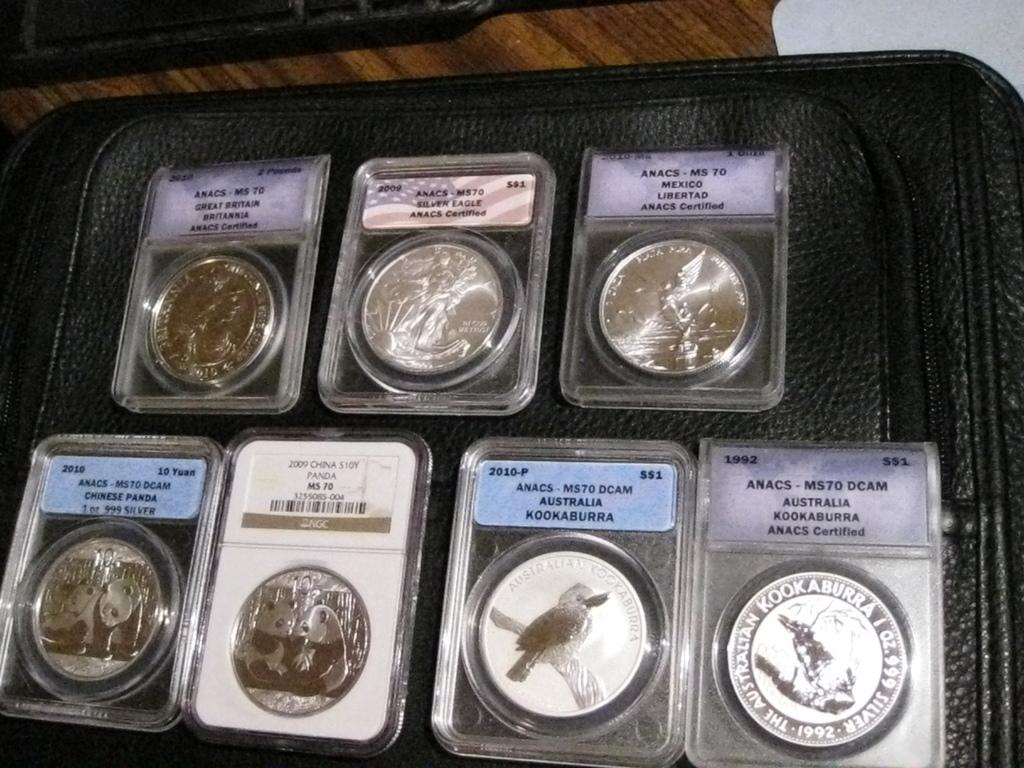Provide a one-sentence caption for the provided image. Collection of coins with one saying "Australia Kookaburra" on it. 